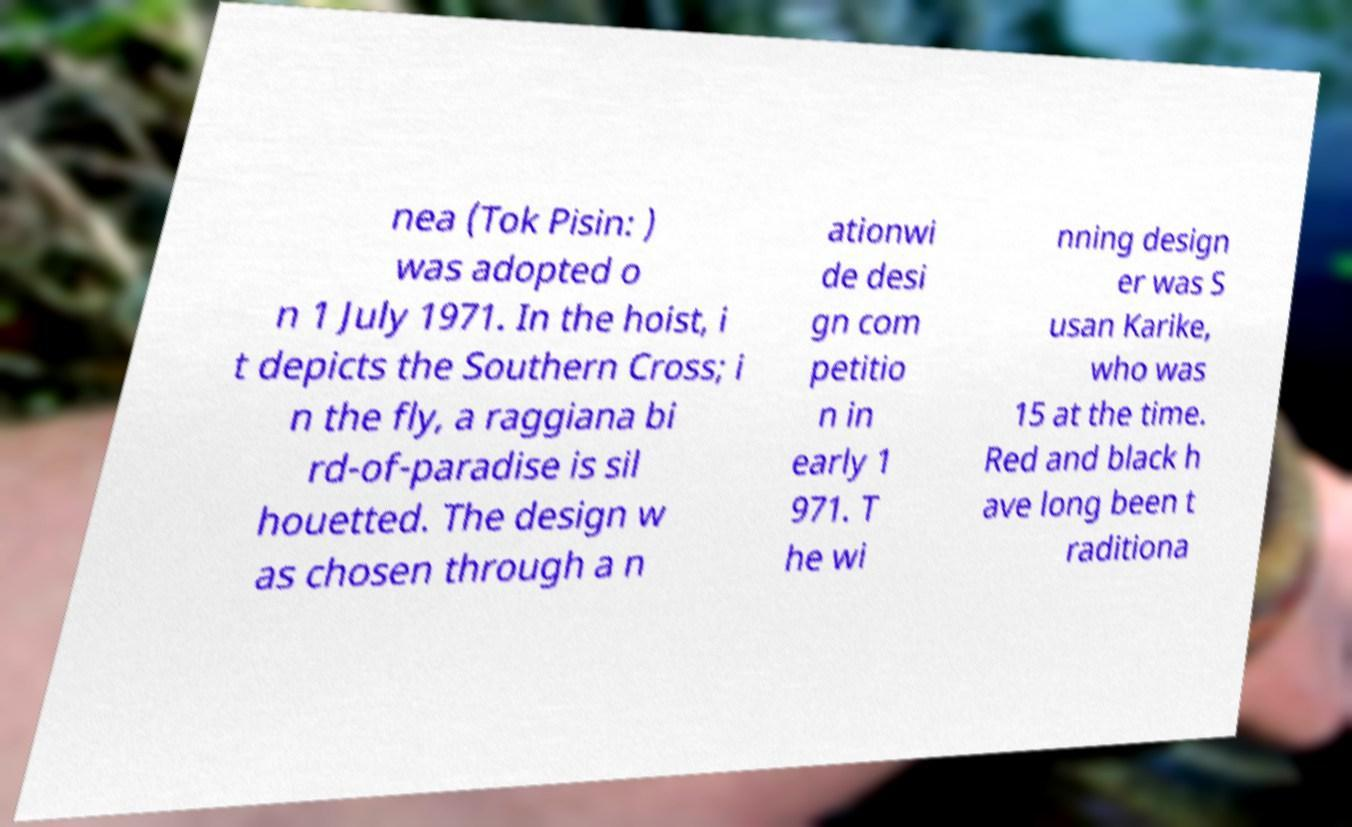For documentation purposes, I need the text within this image transcribed. Could you provide that? nea (Tok Pisin: ) was adopted o n 1 July 1971. In the hoist, i t depicts the Southern Cross; i n the fly, a raggiana bi rd-of-paradise is sil houetted. The design w as chosen through a n ationwi de desi gn com petitio n in early 1 971. T he wi nning design er was S usan Karike, who was 15 at the time. Red and black h ave long been t raditiona 